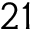<formula> <loc_0><loc_0><loc_500><loc_500>2 1</formula> 